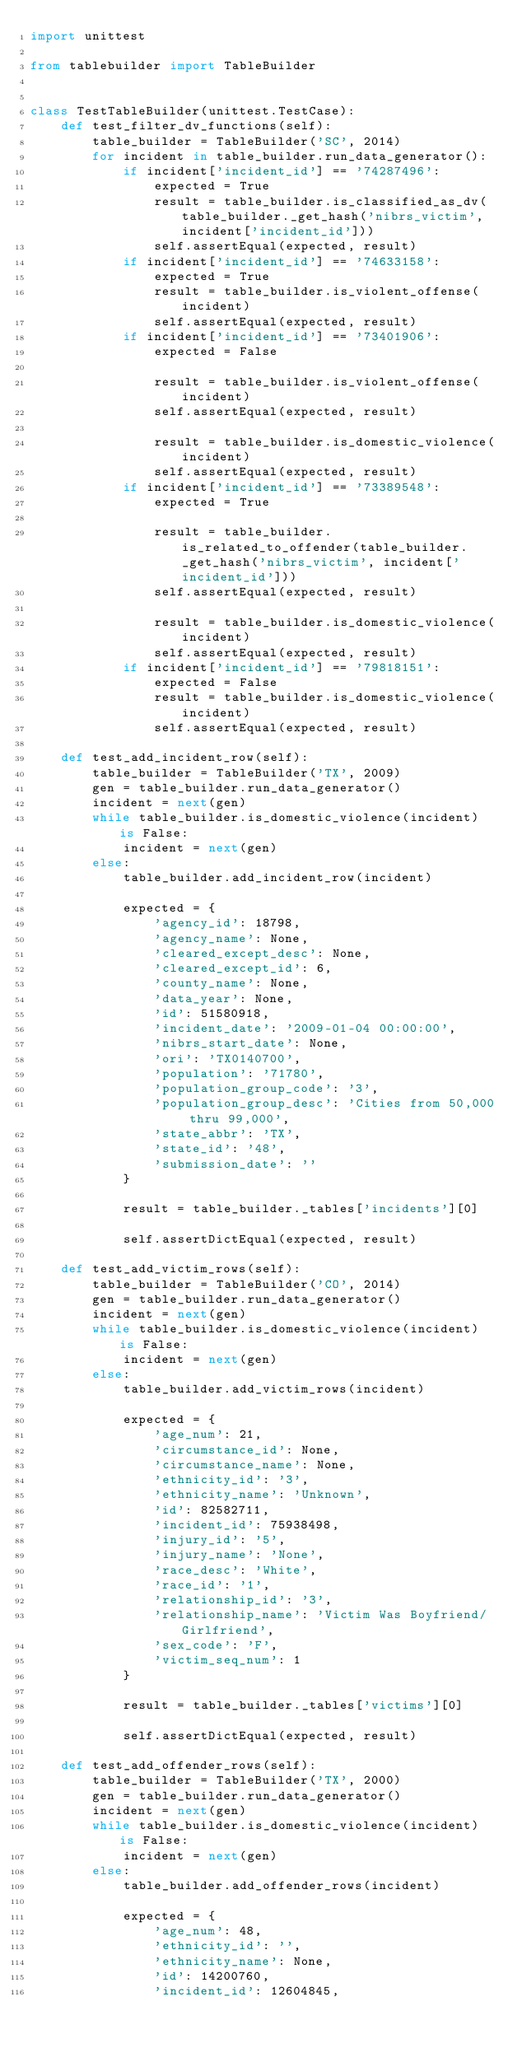Convert code to text. <code><loc_0><loc_0><loc_500><loc_500><_Python_>import unittest

from tablebuilder import TableBuilder


class TestTableBuilder(unittest.TestCase):
    def test_filter_dv_functions(self):
        table_builder = TableBuilder('SC', 2014)
        for incident in table_builder.run_data_generator():
            if incident['incident_id'] == '74287496':
                expected = True
                result = table_builder.is_classified_as_dv(table_builder._get_hash('nibrs_victim', incident['incident_id']))
                self.assertEqual(expected, result)
            if incident['incident_id'] == '74633158':
                expected = True
                result = table_builder.is_violent_offense(incident)
                self.assertEqual(expected, result)
            if incident['incident_id'] == '73401906':
                expected = False

                result = table_builder.is_violent_offense(incident)
                self.assertEqual(expected, result)

                result = table_builder.is_domestic_violence(incident)
                self.assertEqual(expected, result)
            if incident['incident_id'] == '73389548':
                expected = True

                result = table_builder.is_related_to_offender(table_builder._get_hash('nibrs_victim', incident['incident_id']))
                self.assertEqual(expected, result)

                result = table_builder.is_domestic_violence(incident)
                self.assertEqual(expected, result)
            if incident['incident_id'] == '79818151':
                expected = False
                result = table_builder.is_domestic_violence(incident)
                self.assertEqual(expected, result)

    def test_add_incident_row(self):
        table_builder = TableBuilder('TX', 2009)
        gen = table_builder.run_data_generator()
        incident = next(gen)
        while table_builder.is_domestic_violence(incident) is False:
            incident = next(gen)
        else:
            table_builder.add_incident_row(incident)

            expected = {
                'agency_id': 18798,
                'agency_name': None,
                'cleared_except_desc': None,
                'cleared_except_id': 6,
                'county_name': None,
                'data_year': None,
                'id': 51580918,
                'incident_date': '2009-01-04 00:00:00',
                'nibrs_start_date': None,
                'ori': 'TX0140700',
                'population': '71780',
                'population_group_code': '3',
                'population_group_desc': 'Cities from 50,000 thru 99,000',
                'state_abbr': 'TX',
                'state_id': '48',
                'submission_date': ''
            }

            result = table_builder._tables['incidents'][0]

            self.assertDictEqual(expected, result)

    def test_add_victim_rows(self):
        table_builder = TableBuilder('CO', 2014)
        gen = table_builder.run_data_generator()
        incident = next(gen)
        while table_builder.is_domestic_violence(incident) is False:
            incident = next(gen)
        else:
            table_builder.add_victim_rows(incident)

            expected = {
                'age_num': 21,
                'circumstance_id': None,
                'circumstance_name': None,
                'ethnicity_id': '3',
                'ethnicity_name': 'Unknown',
                'id': 82582711,
                'incident_id': 75938498,
                'injury_id': '5',
                'injury_name': 'None',
                'race_desc': 'White',
                'race_id': '1',
                'relationship_id': '3',
                'relationship_name': 'Victim Was Boyfriend/Girlfriend',
                'sex_code': 'F',
                'victim_seq_num': 1
            }

            result = table_builder._tables['victims'][0]

            self.assertDictEqual(expected, result)

    def test_add_offender_rows(self):
        table_builder = TableBuilder('TX', 2000)
        gen = table_builder.run_data_generator()
        incident = next(gen)
        while table_builder.is_domestic_violence(incident) is False:
            incident = next(gen)
        else:
            table_builder.add_offender_rows(incident)

            expected = {
                'age_num': 48,
                'ethnicity_id': '',
                'ethnicity_name': None,
                'id': 14200760,
                'incident_id': 12604845,</code> 